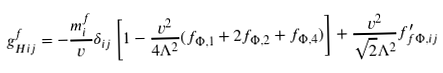Convert formula to latex. <formula><loc_0><loc_0><loc_500><loc_500>g ^ { f } _ { H i j } = - \frac { m ^ { f } _ { i } } { v } \delta _ { i j } \left [ 1 - \frac { v ^ { 2 } } { 4 \Lambda ^ { 2 } } ( f _ { \Phi , 1 } + 2 f _ { \Phi , 2 } + f _ { \Phi , 4 } ) \right ] + \frac { v ^ { 2 } } { \sqrt { 2 } \Lambda ^ { 2 } } f ^ { \prime } _ { f \Phi , i j }</formula> 